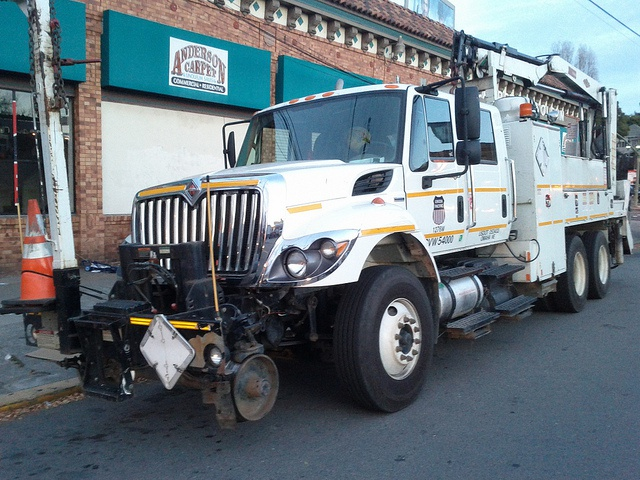Describe the objects in this image and their specific colors. I can see truck in teal, black, white, gray, and darkgray tones and people in teal, gray, and blue tones in this image. 